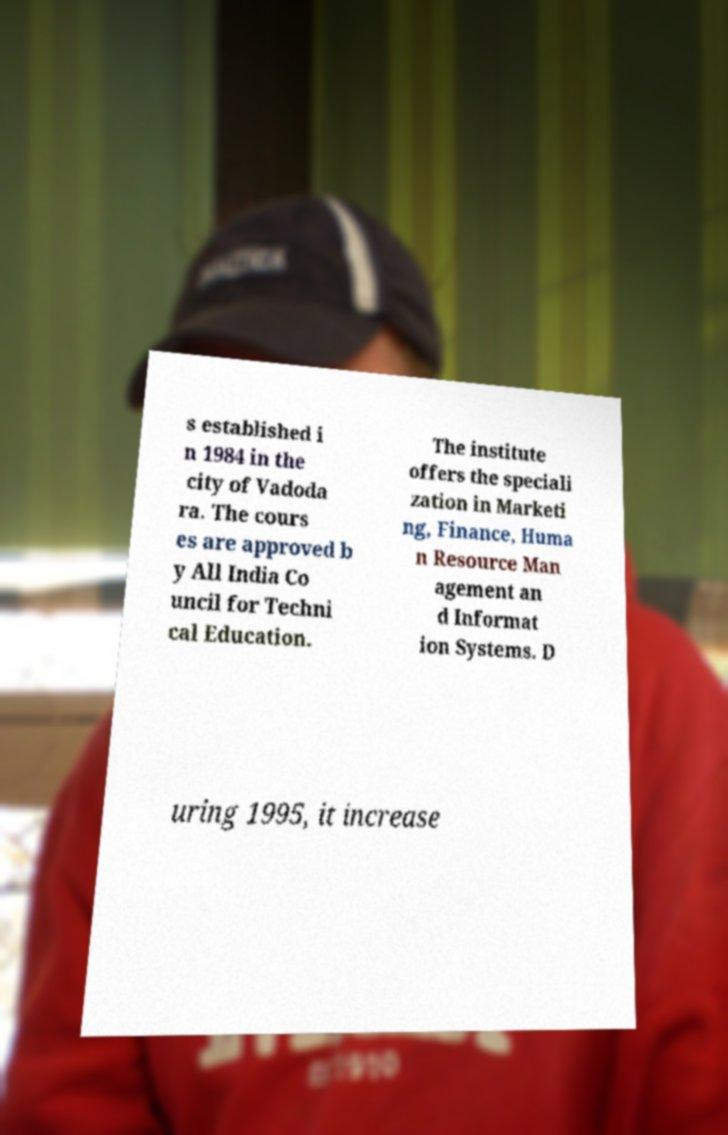Could you extract and type out the text from this image? s established i n 1984 in the city of Vadoda ra. The cours es are approved b y All India Co uncil for Techni cal Education. The institute offers the speciali zation in Marketi ng, Finance, Huma n Resource Man agement an d Informat ion Systems. D uring 1995, it increase 